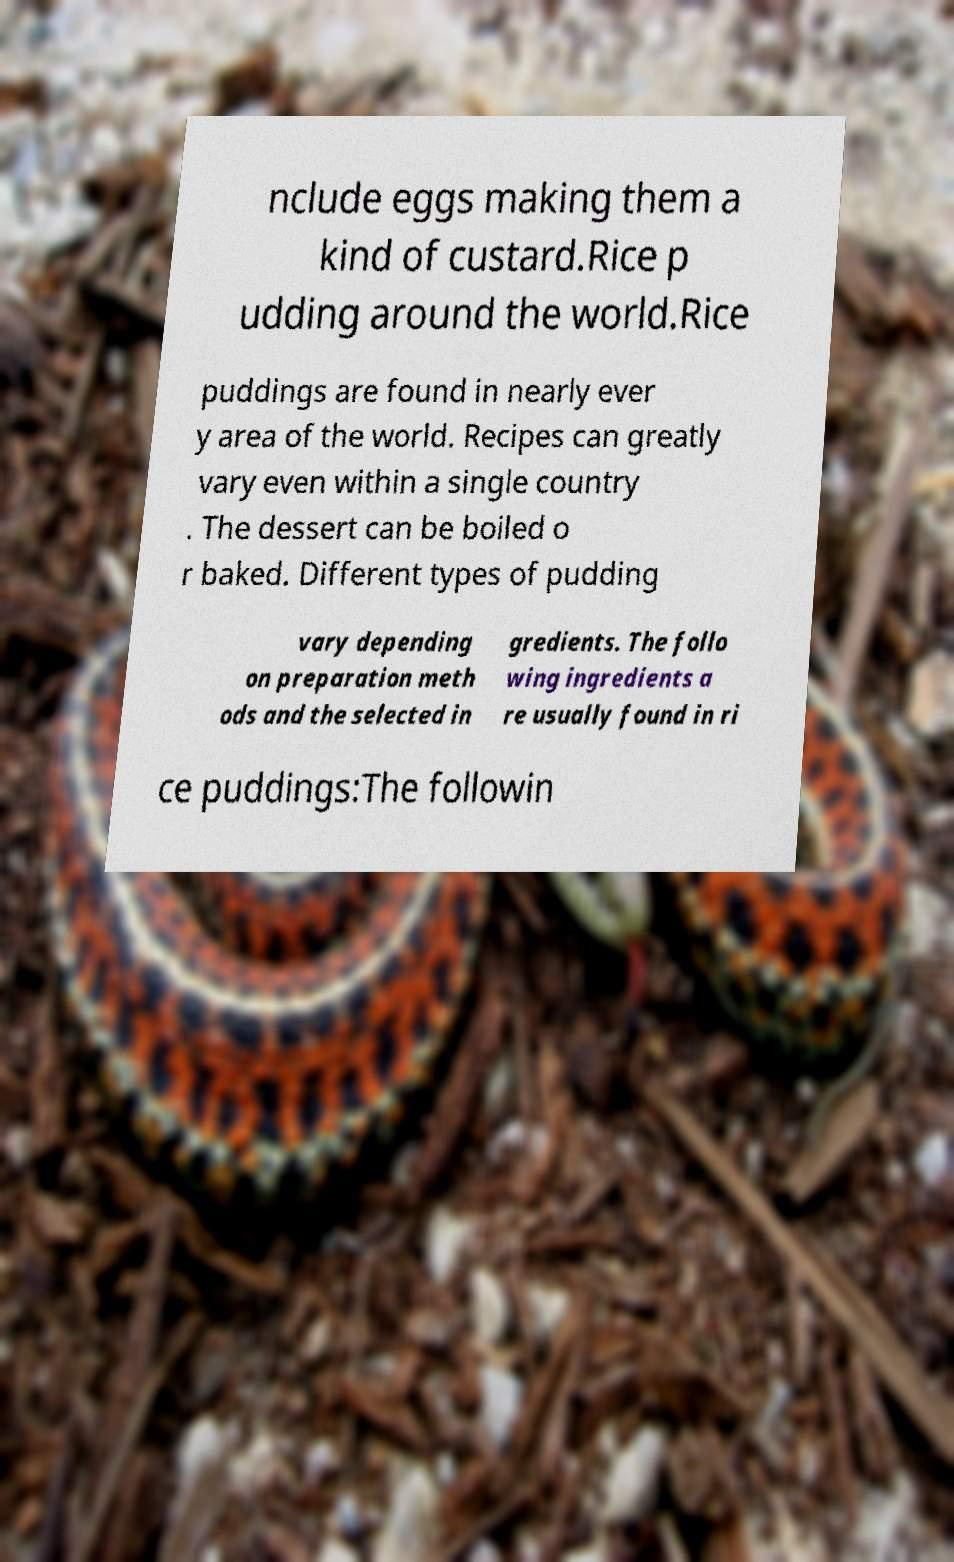Could you assist in decoding the text presented in this image and type it out clearly? nclude eggs making them a kind of custard.Rice p udding around the world.Rice puddings are found in nearly ever y area of the world. Recipes can greatly vary even within a single country . The dessert can be boiled o r baked. Different types of pudding vary depending on preparation meth ods and the selected in gredients. The follo wing ingredients a re usually found in ri ce puddings:The followin 